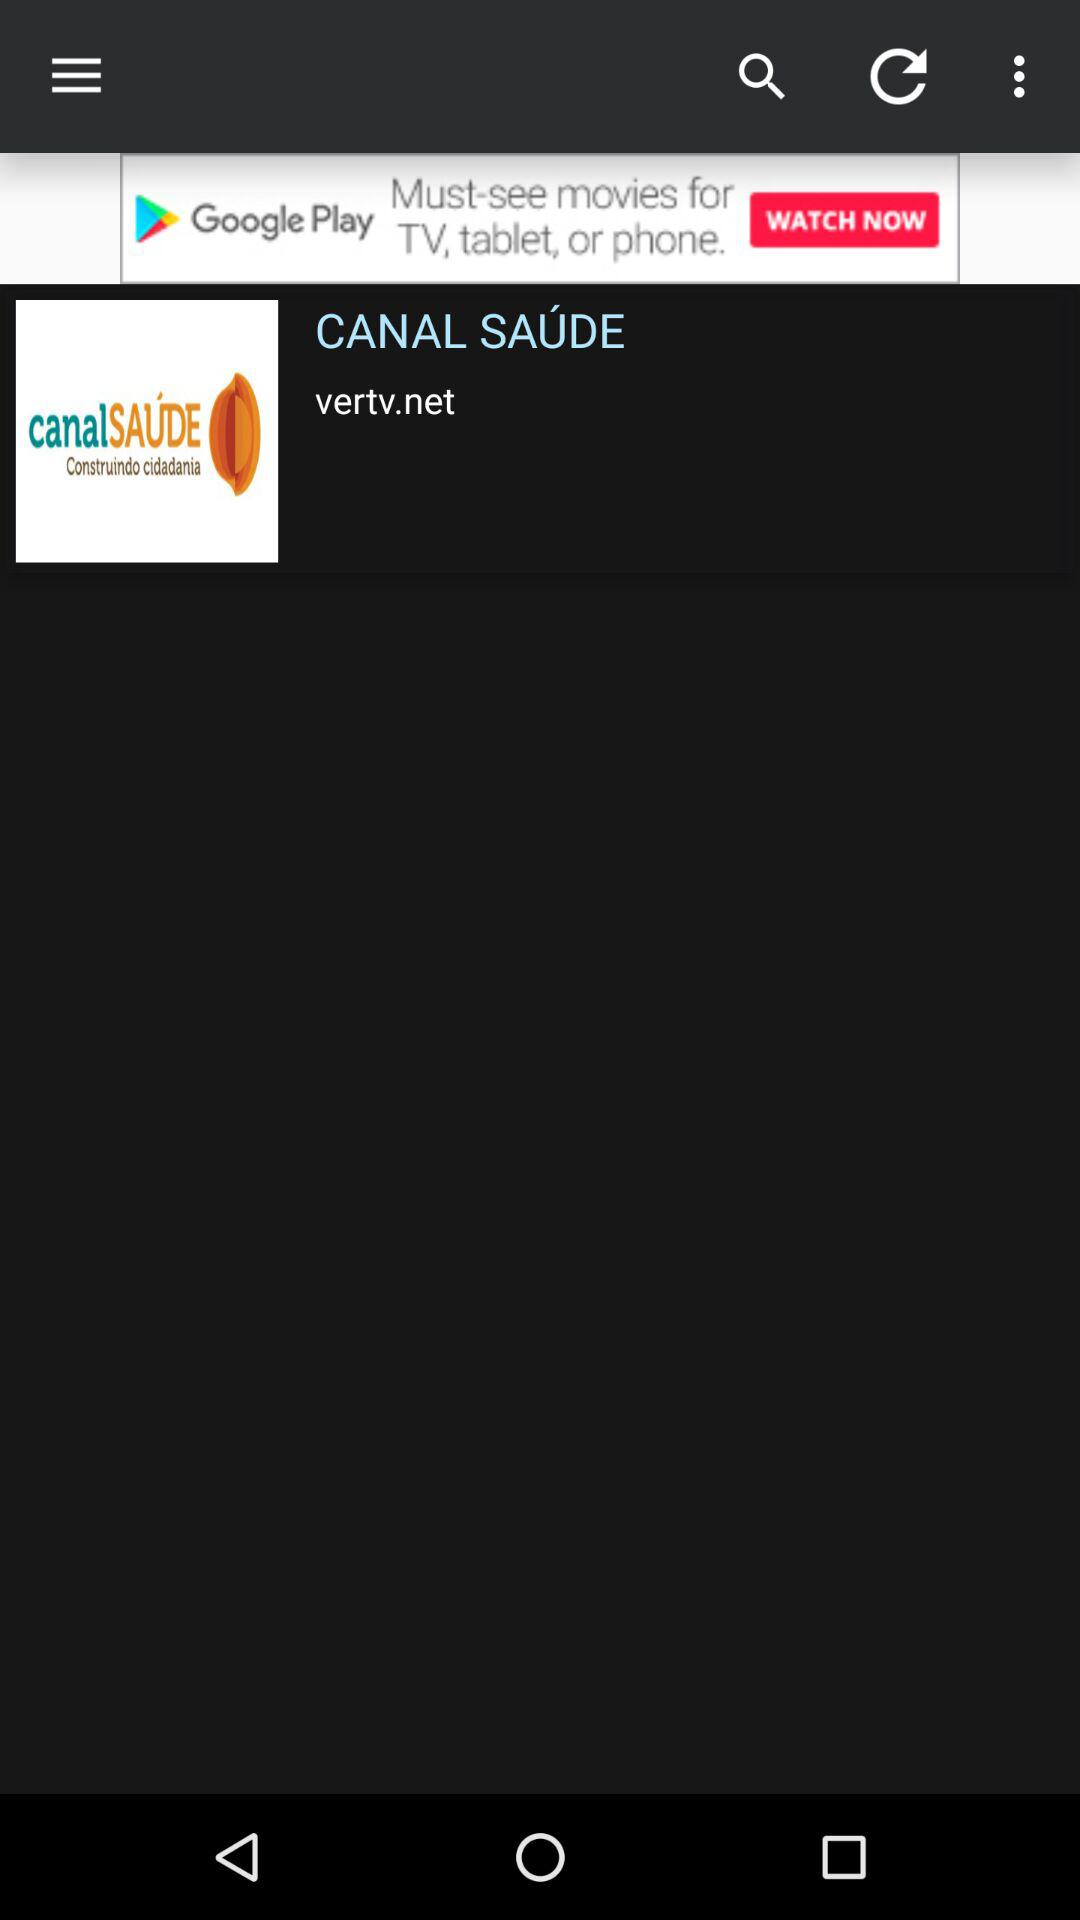What is the app name? The app name is "CANAL SAÚDE". 